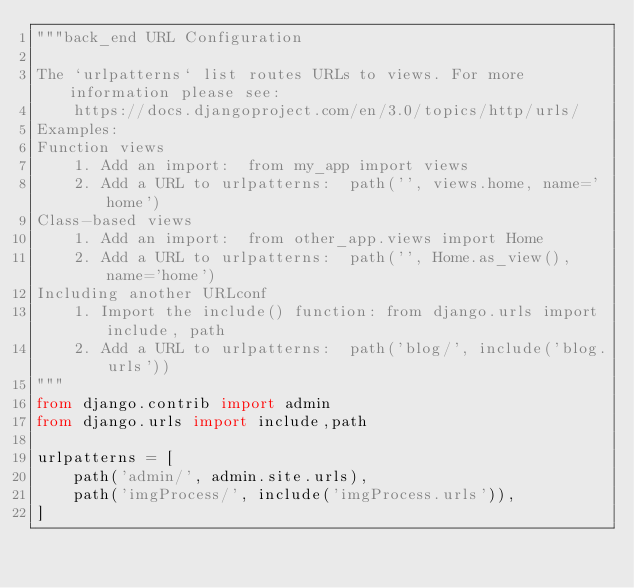<code> <loc_0><loc_0><loc_500><loc_500><_Python_>"""back_end URL Configuration

The `urlpatterns` list routes URLs to views. For more information please see:
    https://docs.djangoproject.com/en/3.0/topics/http/urls/
Examples:
Function views
    1. Add an import:  from my_app import views
    2. Add a URL to urlpatterns:  path('', views.home, name='home')
Class-based views
    1. Add an import:  from other_app.views import Home
    2. Add a URL to urlpatterns:  path('', Home.as_view(), name='home')
Including another URLconf
    1. Import the include() function: from django.urls import include, path
    2. Add a URL to urlpatterns:  path('blog/', include('blog.urls'))
"""
from django.contrib import admin
from django.urls import include,path

urlpatterns = [
    path('admin/', admin.site.urls),
    path('imgProcess/', include('imgProcess.urls')),
]
</code> 